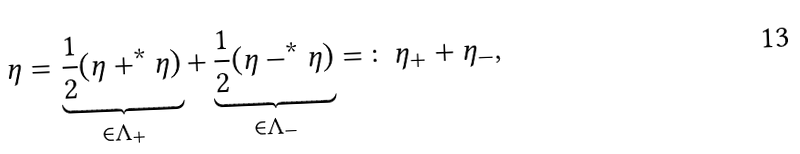Convert formula to latex. <formula><loc_0><loc_0><loc_500><loc_500>\eta = \underbrace { \frac { 1 } { 2 } ( \eta + ^ { * } \eta ) } _ { \in \Lambda _ { + } } + \underbrace { \frac { 1 } { 2 } ( \eta - ^ { * } \eta ) } _ { \in \Lambda _ { - } } = \colon \eta _ { + } + \eta _ { - } ,</formula> 